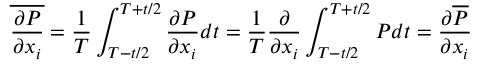Convert formula to latex. <formula><loc_0><loc_0><loc_500><loc_500>\overline { { \frac { \partial P } { \partial x _ { i } } } } = { \frac { 1 } { T } } \int _ { T - t / 2 } ^ { T + t / 2 } { \frac { \partial P } { \partial x _ { i } } } d t = { \frac { 1 } { T } } { \frac { \partial } { \partial x _ { i } } } \int _ { T - t / 2 } ^ { T + t / 2 } P d t = { \frac { \partial \overline { P } } { \partial x _ { i } } }</formula> 